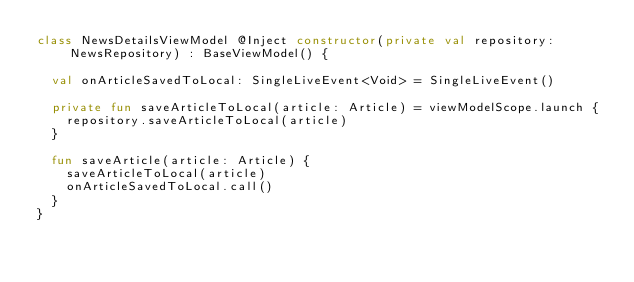Convert code to text. <code><loc_0><loc_0><loc_500><loc_500><_Kotlin_>class NewsDetailsViewModel @Inject constructor(private val repository: NewsRepository) : BaseViewModel() {

  val onArticleSavedToLocal: SingleLiveEvent<Void> = SingleLiveEvent()

  private fun saveArticleToLocal(article: Article) = viewModelScope.launch {
    repository.saveArticleToLocal(article)
  }

  fun saveArticle(article: Article) {
    saveArticleToLocal(article)
    onArticleSavedToLocal.call()
  }
}</code> 